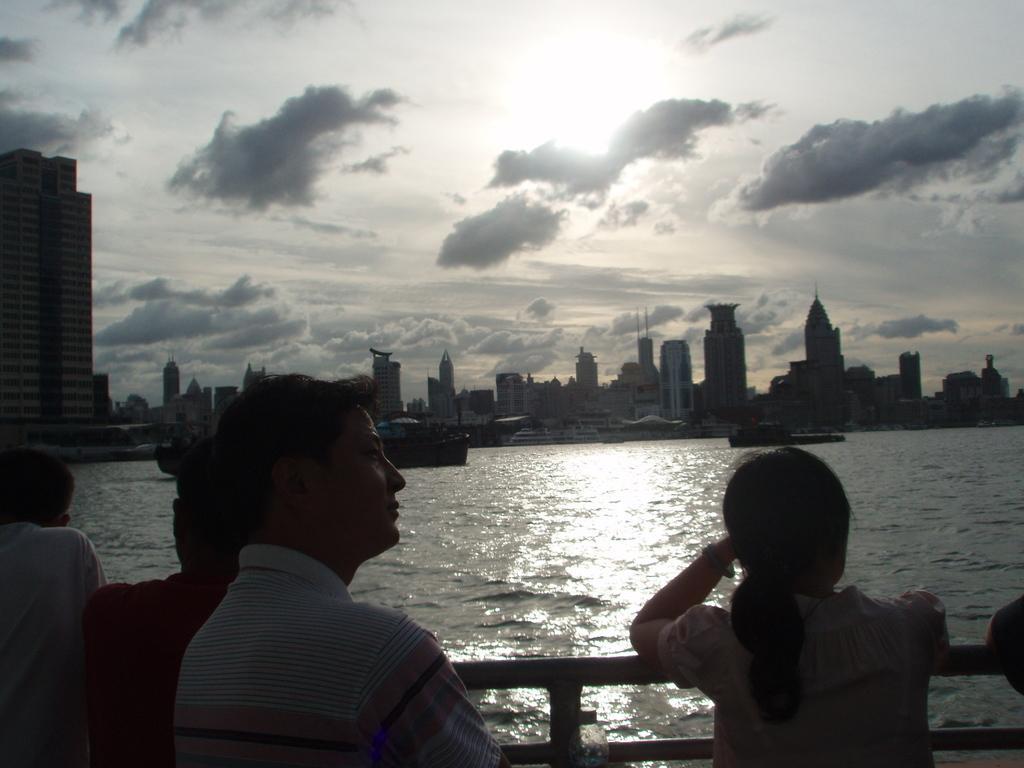How would you summarize this image in a sentence or two? In this image I can see a person wearing white, pink and blue colored shirt is standing, few persons standing, the railing and the water. In the background I an see few boats on the surface of the water, few buildings and the sky. 